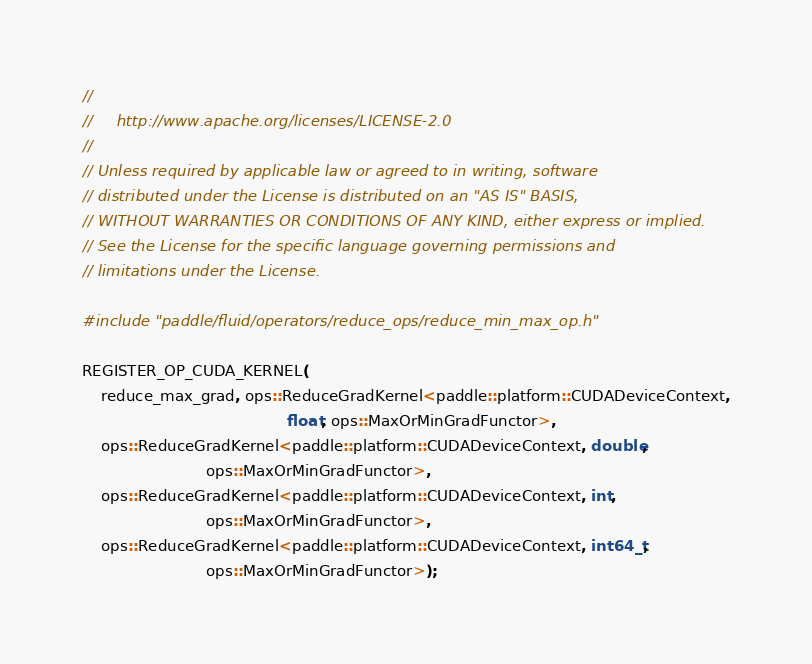Convert code to text. <code><loc_0><loc_0><loc_500><loc_500><_Cuda_>//
//     http://www.apache.org/licenses/LICENSE-2.0
//
// Unless required by applicable law or agreed to in writing, software
// distributed under the License is distributed on an "AS IS" BASIS,
// WITHOUT WARRANTIES OR CONDITIONS OF ANY KIND, either express or implied.
// See the License for the specific language governing permissions and
// limitations under the License.

#include "paddle/fluid/operators/reduce_ops/reduce_min_max_op.h"

REGISTER_OP_CUDA_KERNEL(
    reduce_max_grad, ops::ReduceGradKernel<paddle::platform::CUDADeviceContext,
                                           float, ops::MaxOrMinGradFunctor>,
    ops::ReduceGradKernel<paddle::platform::CUDADeviceContext, double,
                          ops::MaxOrMinGradFunctor>,
    ops::ReduceGradKernel<paddle::platform::CUDADeviceContext, int,
                          ops::MaxOrMinGradFunctor>,
    ops::ReduceGradKernel<paddle::platform::CUDADeviceContext, int64_t,
                          ops::MaxOrMinGradFunctor>);
</code> 